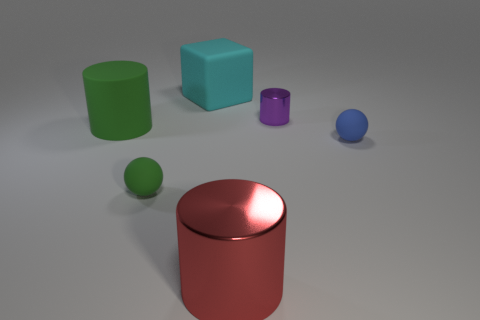Are there an equal number of large cyan matte blocks in front of the green rubber sphere and shiny things that are in front of the red shiny cylinder?
Make the answer very short. Yes. There is a cylinder that is in front of the small cylinder and behind the blue rubber ball; what material is it?
Your answer should be compact. Rubber. Do the purple cylinder and the block that is behind the purple metallic cylinder have the same size?
Your answer should be compact. No. How many other objects are the same color as the large rubber block?
Offer a terse response. 0. Is the number of blue matte balls that are to the right of the tiny blue rubber sphere greater than the number of large green rubber objects?
Provide a short and direct response. No. The shiny cylinder that is in front of the matte ball that is behind the ball that is on the left side of the large red thing is what color?
Your answer should be compact. Red. Is the material of the small blue thing the same as the large green thing?
Ensure brevity in your answer.  Yes. Is there a green matte object of the same size as the cyan block?
Give a very brief answer. Yes. What material is the blue thing that is the same size as the purple thing?
Offer a very short reply. Rubber. Are there any big cyan metal objects of the same shape as the cyan matte object?
Ensure brevity in your answer.  No. 